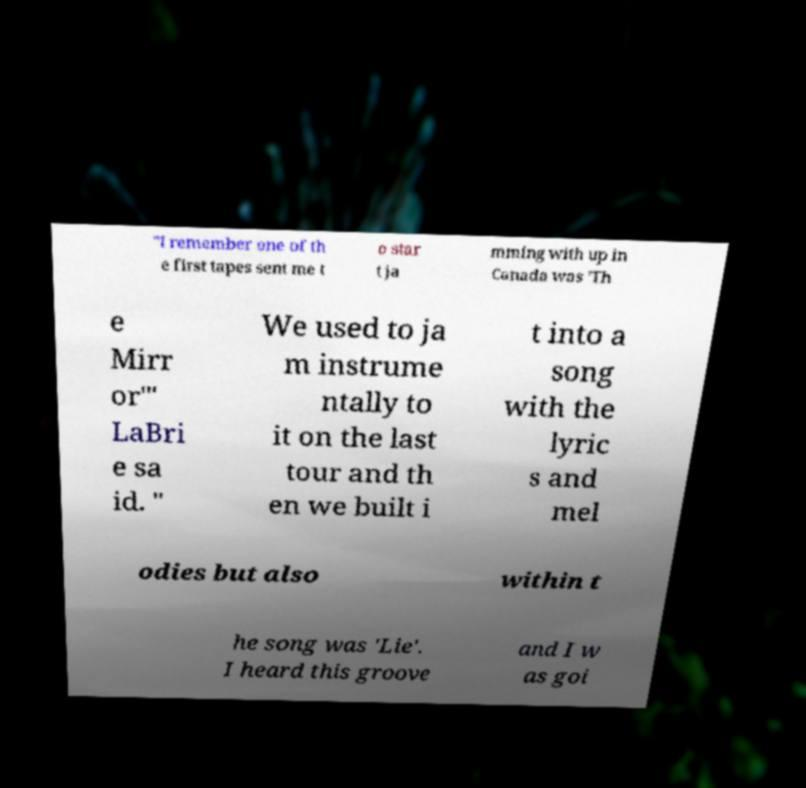There's text embedded in this image that I need extracted. Can you transcribe it verbatim? "I remember one of th e first tapes sent me t o star t ja mming with up in Canada was 'Th e Mirr or'" LaBri e sa id. " We used to ja m instrume ntally to it on the last tour and th en we built i t into a song with the lyric s and mel odies but also within t he song was 'Lie'. I heard this groove and I w as goi 